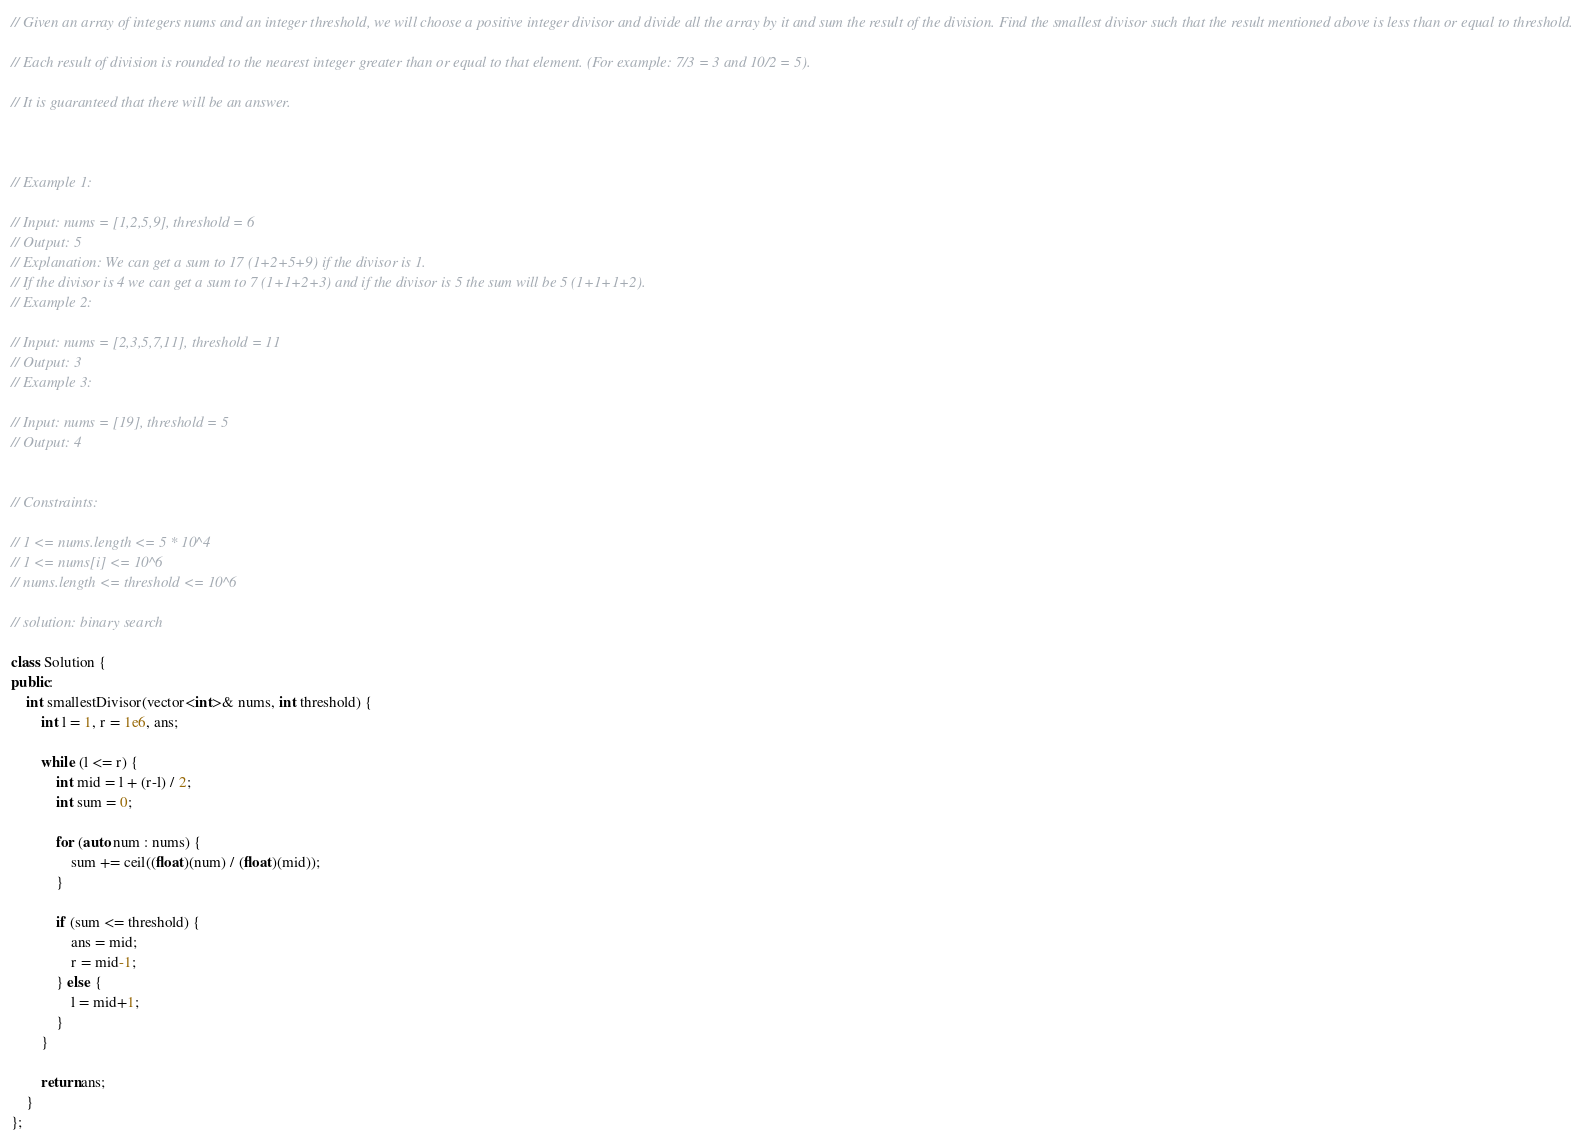<code> <loc_0><loc_0><loc_500><loc_500><_C++_>// Given an array of integers nums and an integer threshold, we will choose a positive integer divisor and divide all the array by it and sum the result of the division. Find the smallest divisor such that the result mentioned above is less than or equal to threshold.

// Each result of division is rounded to the nearest integer greater than or equal to that element. (For example: 7/3 = 3 and 10/2 = 5).

// It is guaranteed that there will be an answer.

 

// Example 1:

// Input: nums = [1,2,5,9], threshold = 6
// Output: 5
// Explanation: We can get a sum to 17 (1+2+5+9) if the divisor is 1. 
// If the divisor is 4 we can get a sum to 7 (1+1+2+3) and if the divisor is 5 the sum will be 5 (1+1+1+2). 
// Example 2:

// Input: nums = [2,3,5,7,11], threshold = 11
// Output: 3
// Example 3:

// Input: nums = [19], threshold = 5
// Output: 4
 

// Constraints:

// 1 <= nums.length <= 5 * 10^4
// 1 <= nums[i] <= 10^6
// nums.length <= threshold <= 10^6

// solution: binary search

class Solution {
public:
    int smallestDivisor(vector<int>& nums, int threshold) {
        int l = 1, r = 1e6, ans;

        while (l <= r) {
            int mid = l + (r-l) / 2;
            int sum = 0;

            for (auto num : nums) {
                sum += ceil((float)(num) / (float)(mid));
            }

            if (sum <= threshold) {
                ans = mid;
                r = mid-1;
            } else {
                l = mid+1;
            }
        }
        
        return ans;
    }
};</code> 